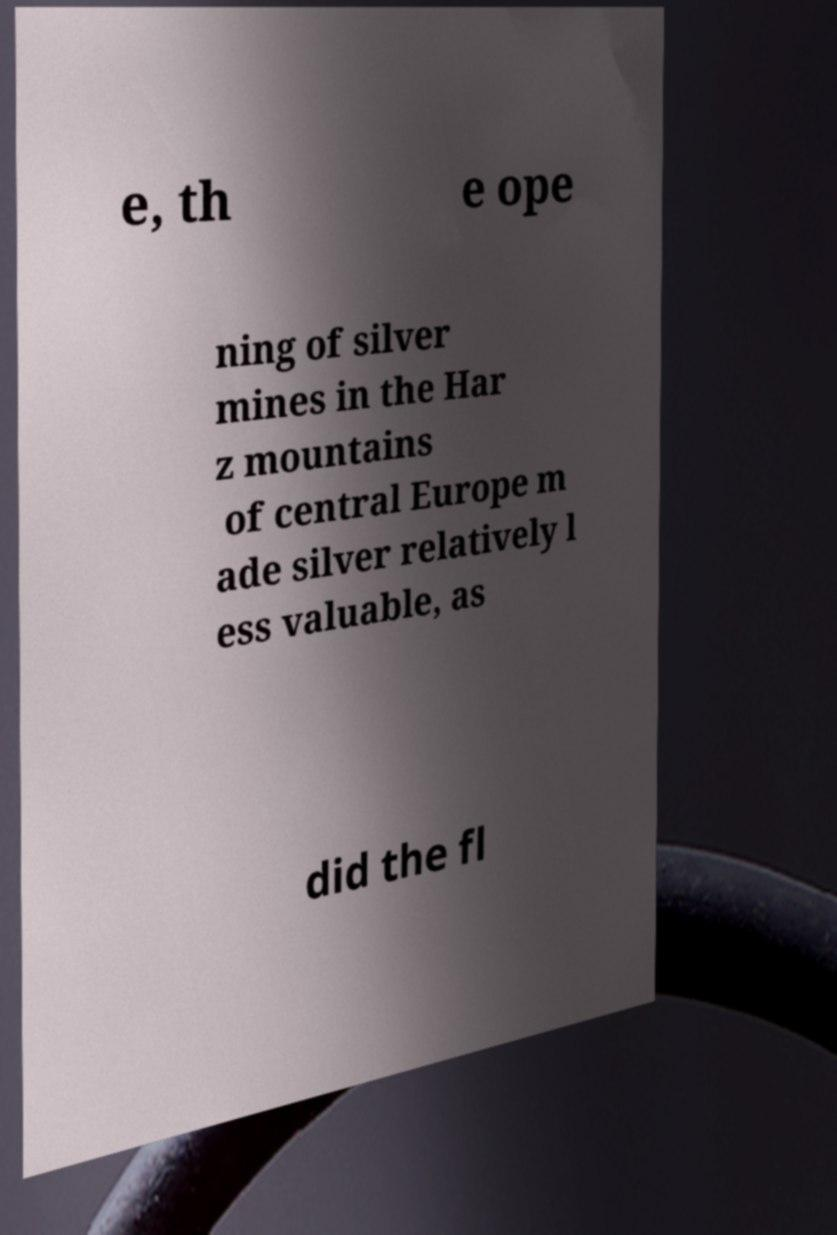Could you assist in decoding the text presented in this image and type it out clearly? e, th e ope ning of silver mines in the Har z mountains of central Europe m ade silver relatively l ess valuable, as did the fl 